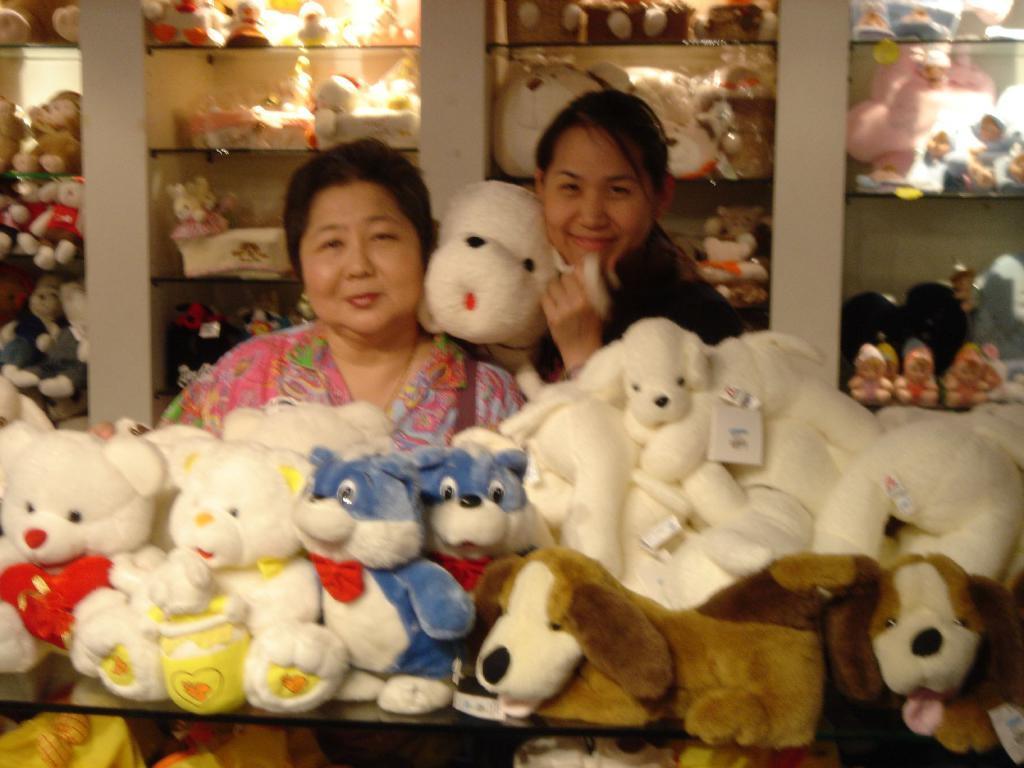Describe this image in one or two sentences. This picture shows few soft toys on the table and we see couple of women with a smile on their faces and a woman holding a soft toy in her hand and we see few soft toys in the shelves on the back. 